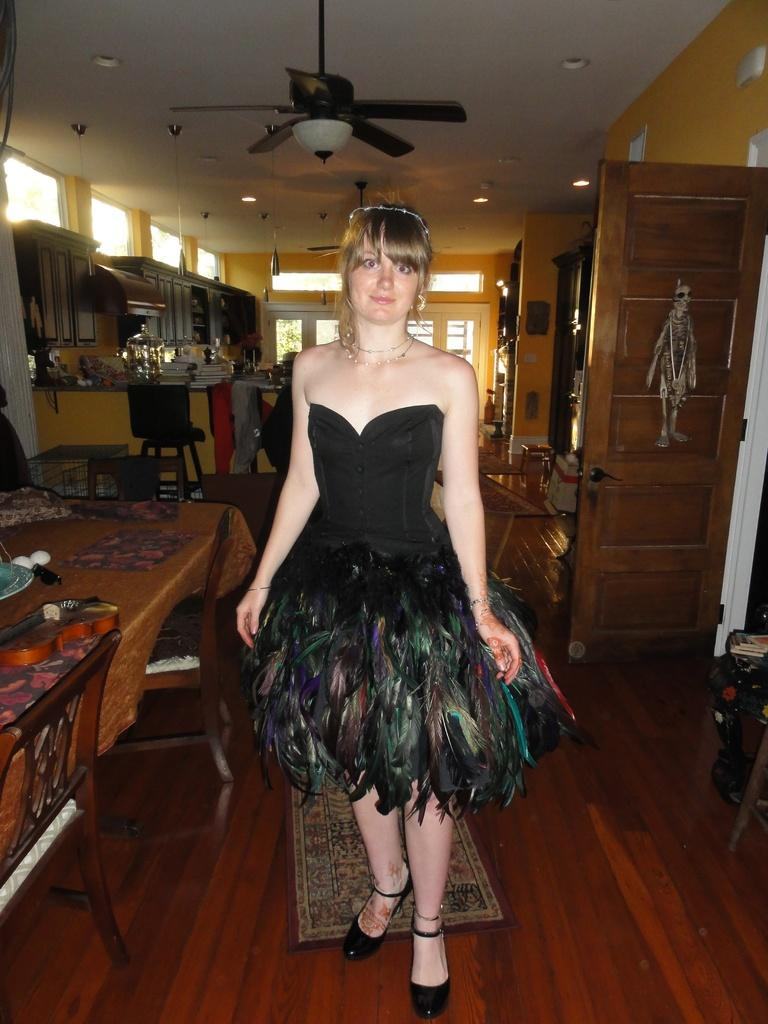Who is the main subject in the image? There is a woman in the image. What is the woman doing in the image? The woman is posing for the camera. What is the woman wearing in the image? The woman is wearing a dress. What is unique about the dress the woman is wearing? The dress has feathers attached to it. What other object can be seen beside the woman? There is a table beside the woman. What is the purpose of the fan in the image? There is a fan attached to the roof, which might be used for cooling or ventilation. What type of pancake is being served on the island in the image? There is no pancake or island present in the image; it features a woman posing for the camera while wearing a dress with feathers. How does the sun affect the woman's pose in the image? The image does not provide information about the sun or its effect on the woman's pose. 